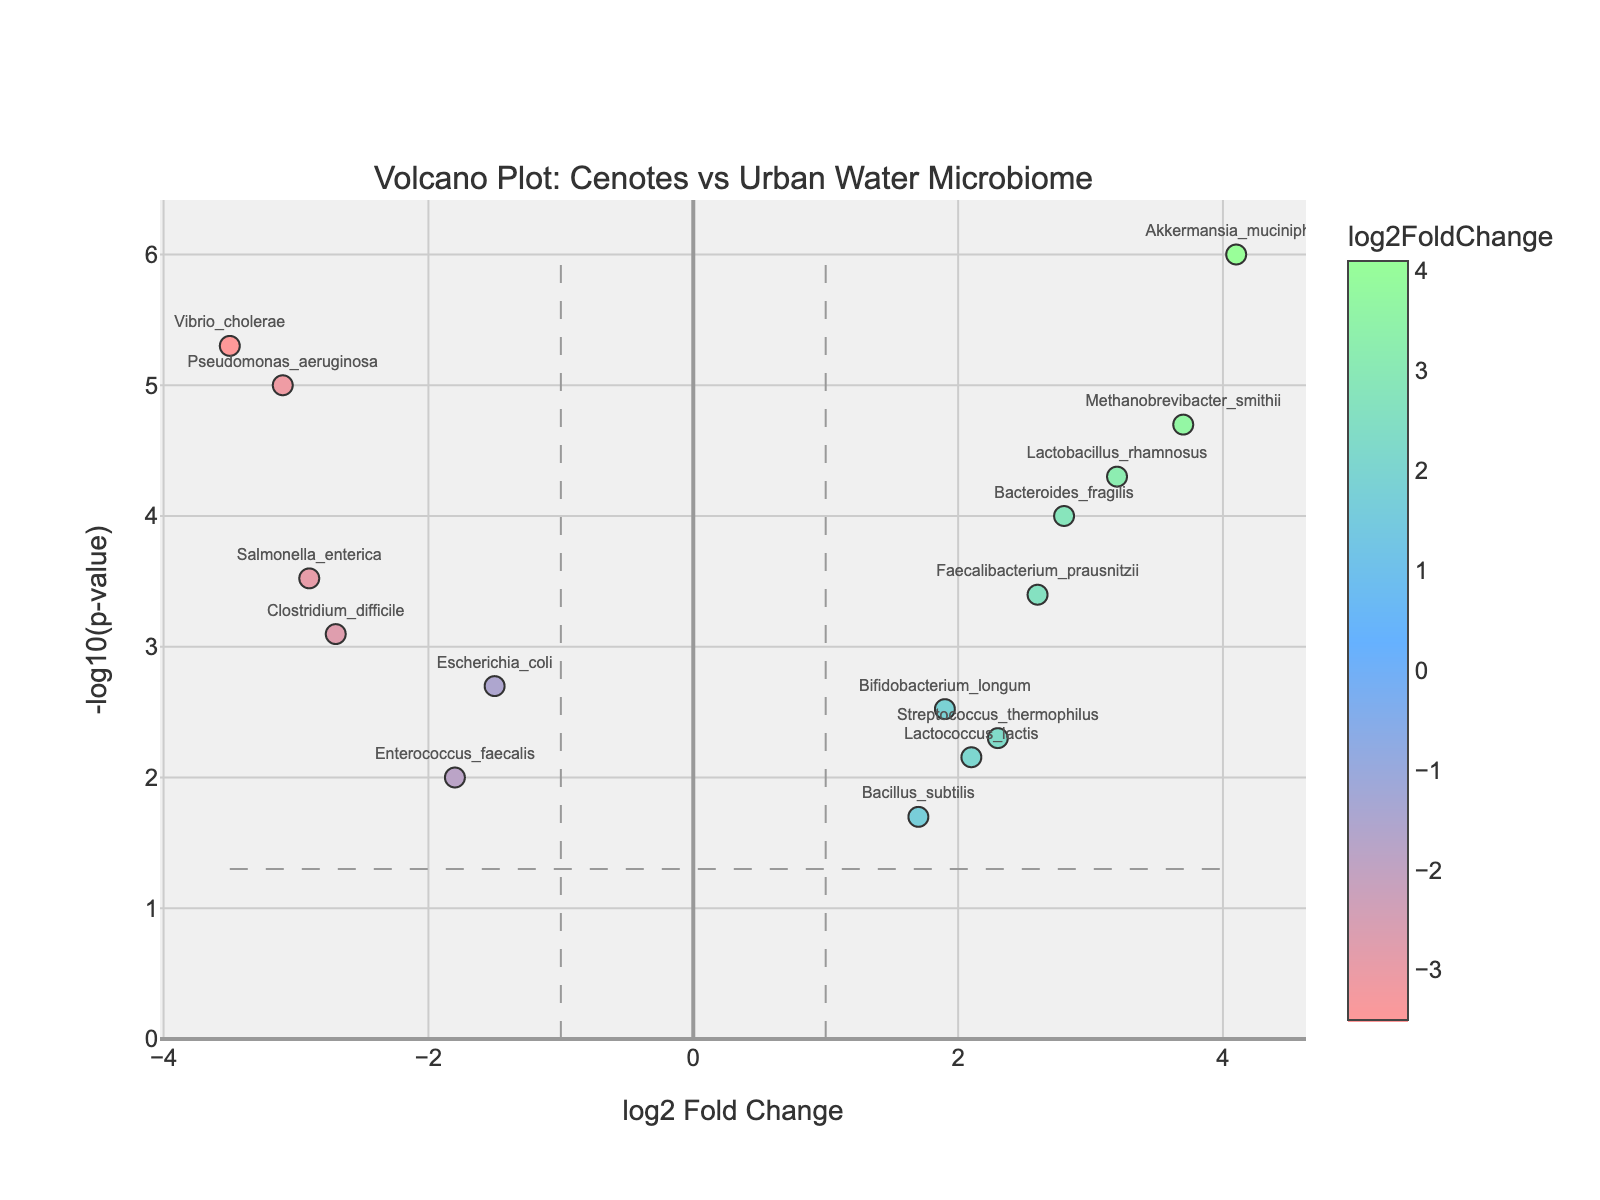what is the title of the plot? The title of the plot can be found at the top of the figure. It is the text that describes what the plot is displaying.
Answer: Volcano Plot: Cenotes vs Urban Water Microbiome How many genes are plotted in the figure? Each data point (dot) on the plot represents a gene, so counting the dots will give the number of genes.
Answer: 15 Which gene has the highest positive log2 Fold Change? The highest log2 Fold Change value is represented by the most rightward point on the x-axis.
Answer: Akkermansia_muciniphila Which gene has the highest negative log2 Fold Change? The lowest log2 Fold Change value (most leftward point on the x-axis) corresponds to the gene with the highest negative change.
Answer: Vibrio_cholerae What does the y-axis represent? The y-axis title describes what this axis represents in the figure.
Answer: -log10(p-value) How many genes have a p-value less than 0.05? Genes with a significant p-value (less than 0.05) will be above the horizontal line at y = -log10(0.05).
Answer: 11 Which gene has the smallest p-value? The smallest p-value corresponds to the highest point on the y-axis.
Answer: Akkermansia_muciniphila What is the p-value threshold represented by the horizontal line? The y-coordinate of the horizontal line dividing significant and non-significant points denotes the -log10 of the p-value threshold (0.05).
Answer: -log10(0.05) = 1.301 Compare the p-value of Bacteroides_fragilis and Pseudomonas_aeruginosa. Which is smaller? By locating the specific genes in the figure, the gene with less y-coordinate value has a higher (less significant) p-value.
Answer: Pseudomonas_aeruginosa Which genes are enriched in Cenotes water compared to urban water sources? Look for the genes on the right side of the vertical line at log2 Fold Change = 1, indicating higher expression in Cenotes samples.
Answer: Akkermansia_muciniphila, Methanobrevibacter_smithii, Lactobacillus_rhamnosus, Bacteroides_fragilis, Faecalibacterium_prausnitzii, Streptococcus_thermophilus, Lactococcus_lactis 